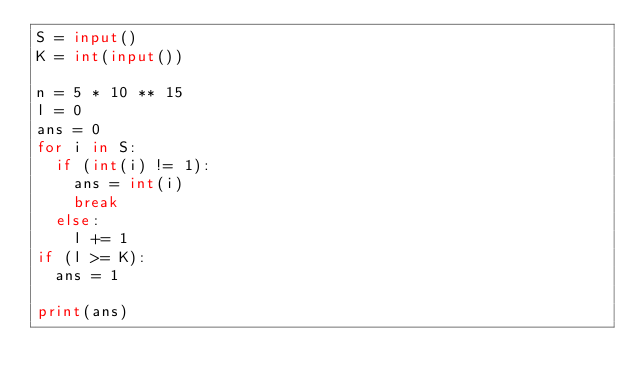Convert code to text. <code><loc_0><loc_0><loc_500><loc_500><_Python_>S = input()
K = int(input())

n = 5 * 10 ** 15
l = 0
ans = 0
for i in S:
  if (int(i) != 1):
    ans = int(i)
    break
  else:
    l += 1
if (l >= K):
  ans = 1

print(ans)
</code> 